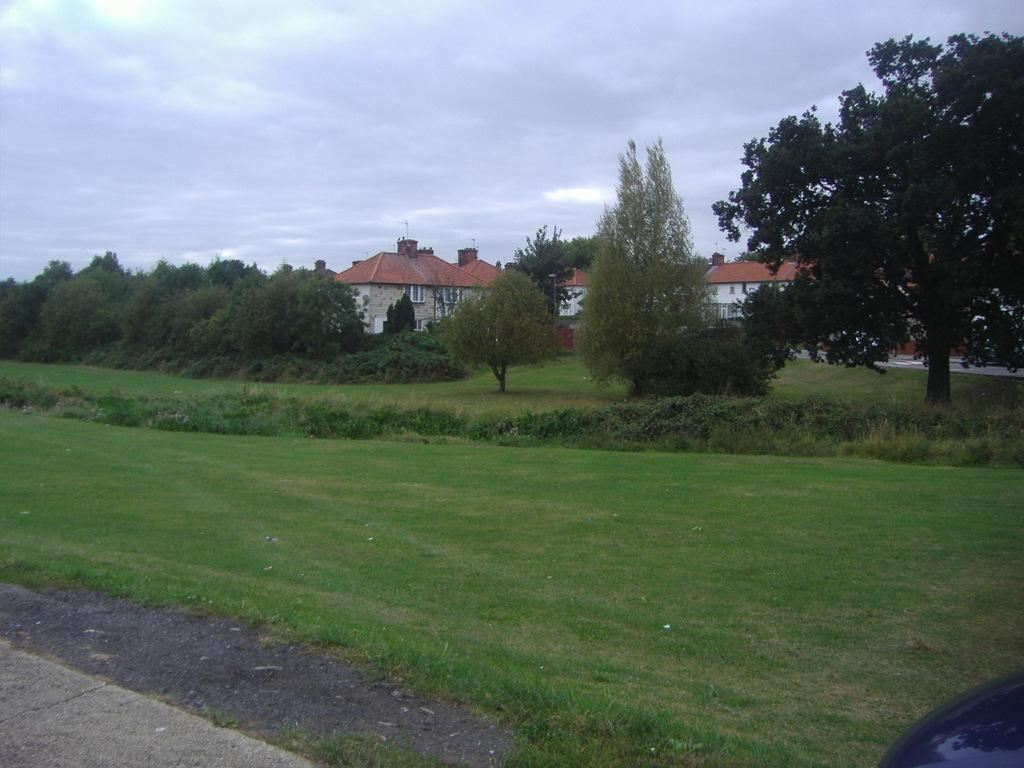What type of ground cover is visible in the image? There is grass on the ground in the image. How are the plants arranged in the image? The plants are arranged from left to right in the image. What can be seen in the background of the image? There are trees and houses in the background of the image. What is the condition of the sky in the image? The sky is cloudy in the image. What type of grain is being harvested in the image? There is no grain present in the image. What is the plot of the story being told in the image? There is no story or plot depicted in the image; it is a scene of grass, plants trees houses, and a cloudy sky. 